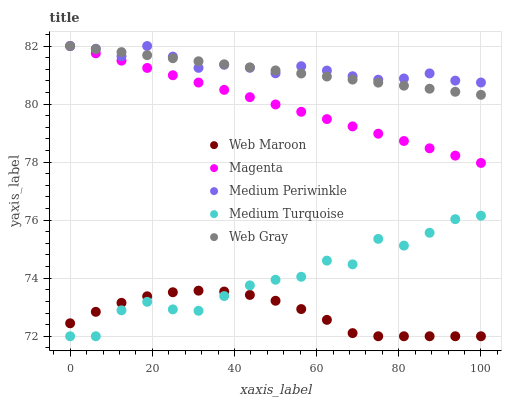Does Web Maroon have the minimum area under the curve?
Answer yes or no. Yes. Does Medium Periwinkle have the maximum area under the curve?
Answer yes or no. Yes. Does Magenta have the minimum area under the curve?
Answer yes or no. No. Does Magenta have the maximum area under the curve?
Answer yes or no. No. Is Magenta the smoothest?
Answer yes or no. Yes. Is Medium Turquoise the roughest?
Answer yes or no. Yes. Is Web Gray the smoothest?
Answer yes or no. No. Is Web Gray the roughest?
Answer yes or no. No. Does Web Maroon have the lowest value?
Answer yes or no. Yes. Does Magenta have the lowest value?
Answer yes or no. No. Does Web Gray have the highest value?
Answer yes or no. Yes. Does Web Maroon have the highest value?
Answer yes or no. No. Is Medium Turquoise less than Magenta?
Answer yes or no. Yes. Is Medium Periwinkle greater than Medium Turquoise?
Answer yes or no. Yes. Does Magenta intersect Medium Periwinkle?
Answer yes or no. Yes. Is Magenta less than Medium Periwinkle?
Answer yes or no. No. Is Magenta greater than Medium Periwinkle?
Answer yes or no. No. Does Medium Turquoise intersect Magenta?
Answer yes or no. No. 